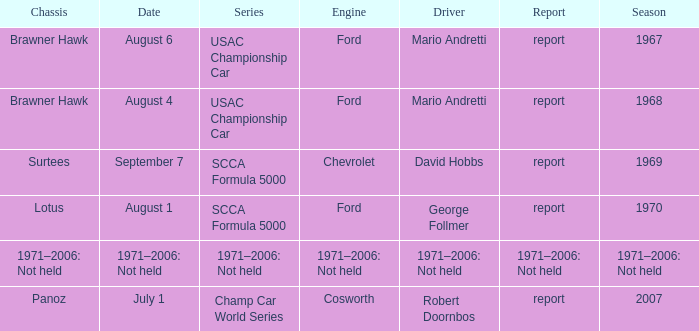Which engine is responsible for the USAC Championship Car? Ford, Ford. 